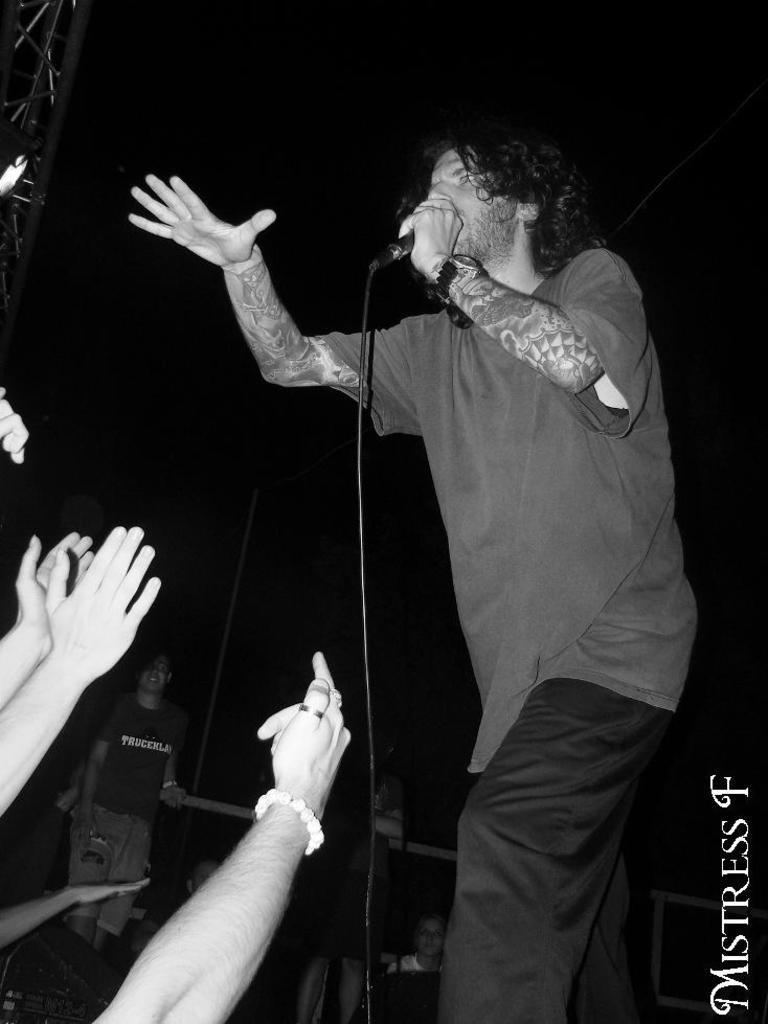Could you give a brief overview of what you see in this image? In this image I can see a person standing and holding a microphone. There are hands of people on the left. The background is dark. 